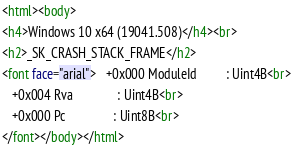<code> <loc_0><loc_0><loc_500><loc_500><_HTML_><html><body>
<h4>Windows 10 x64 (19041.508)</h4><br>
<h2>_SK_CRASH_STACK_FRAME</h2>
<font face="arial">   +0x000 ModuleId         : Uint4B<br>
   +0x004 Rva              : Uint4B<br>
   +0x000 Pc               : Uint8B<br>
</font></body></html></code> 